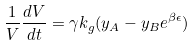<formula> <loc_0><loc_0><loc_500><loc_500>\frac { 1 } { V } \frac { d V } { d t } = \gamma k _ { g } ( y _ { A } - y _ { B } e ^ { \beta \epsilon } )</formula> 